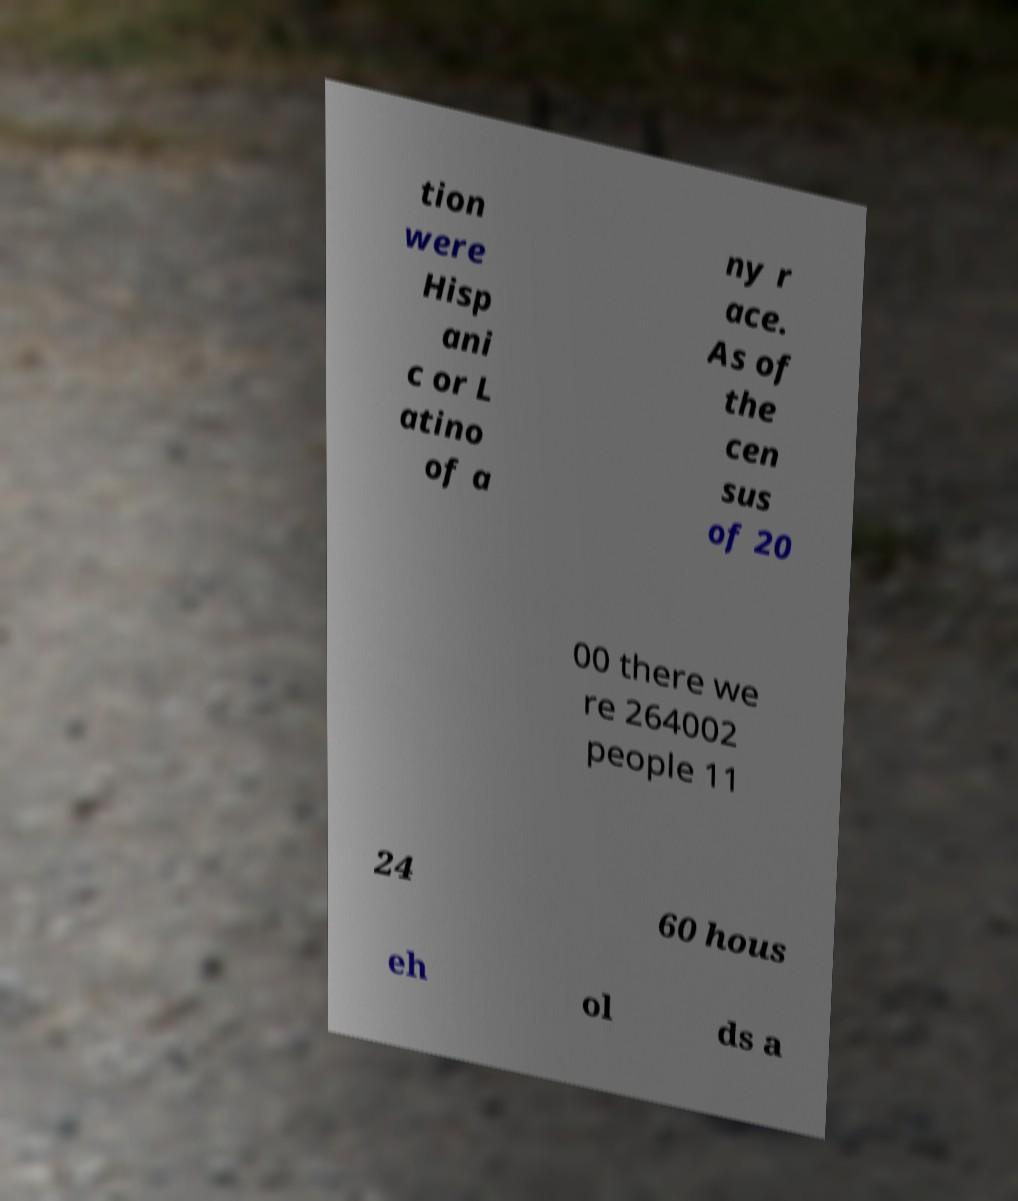I need the written content from this picture converted into text. Can you do that? tion were Hisp ani c or L atino of a ny r ace. As of the cen sus of 20 00 there we re 264002 people 11 24 60 hous eh ol ds a 